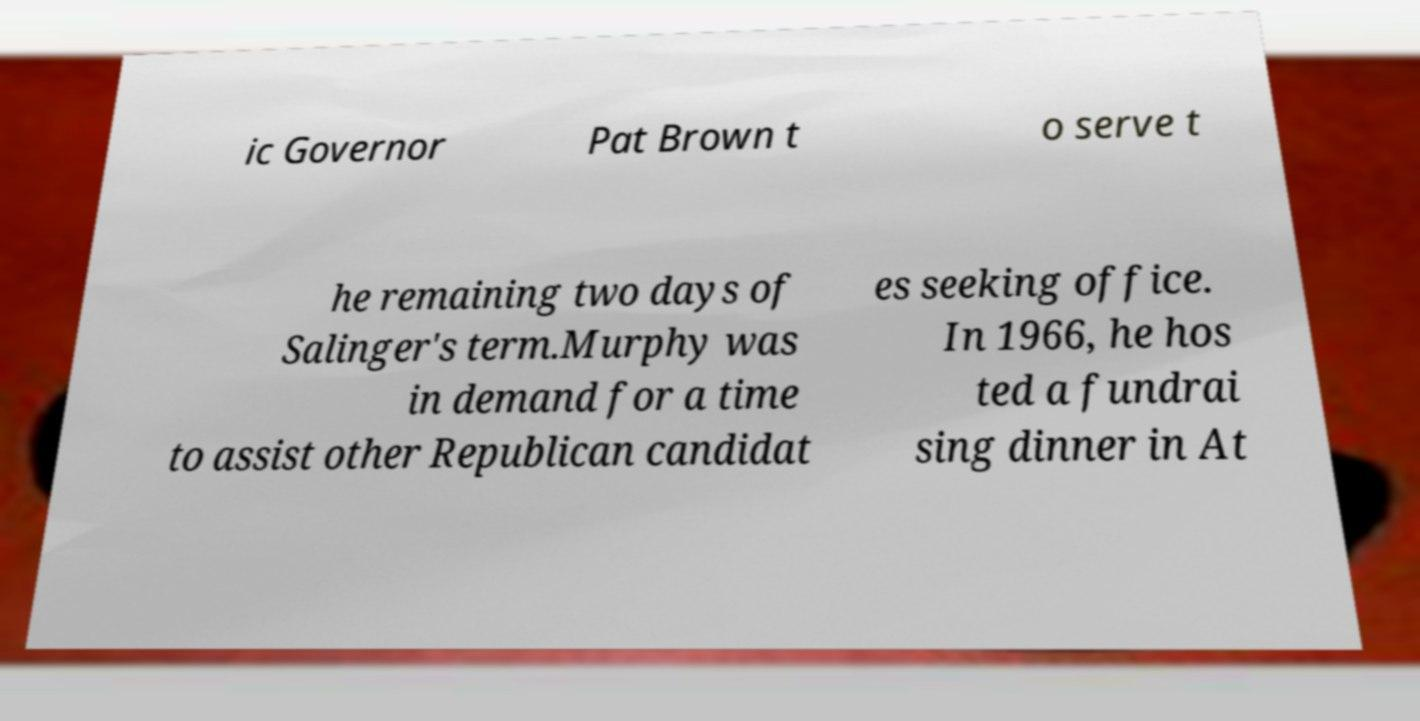What messages or text are displayed in this image? I need them in a readable, typed format. ic Governor Pat Brown t o serve t he remaining two days of Salinger's term.Murphy was in demand for a time to assist other Republican candidat es seeking office. In 1966, he hos ted a fundrai sing dinner in At 